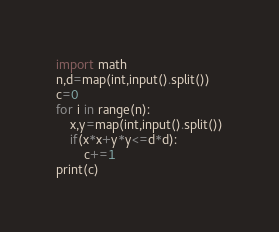Convert code to text. <code><loc_0><loc_0><loc_500><loc_500><_Python_>import math
n,d=map(int,input().split())
c=0
for i in range(n):
    x,y=map(int,input().split())
    if(x*x+y*y<=d*d):
        c+=1
print(c)
</code> 